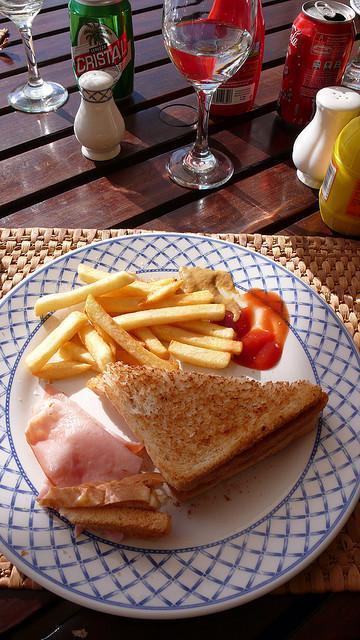How many wine glasses can you see?
Give a very brief answer. 2. How many sandwiches can be seen?
Give a very brief answer. 2. 